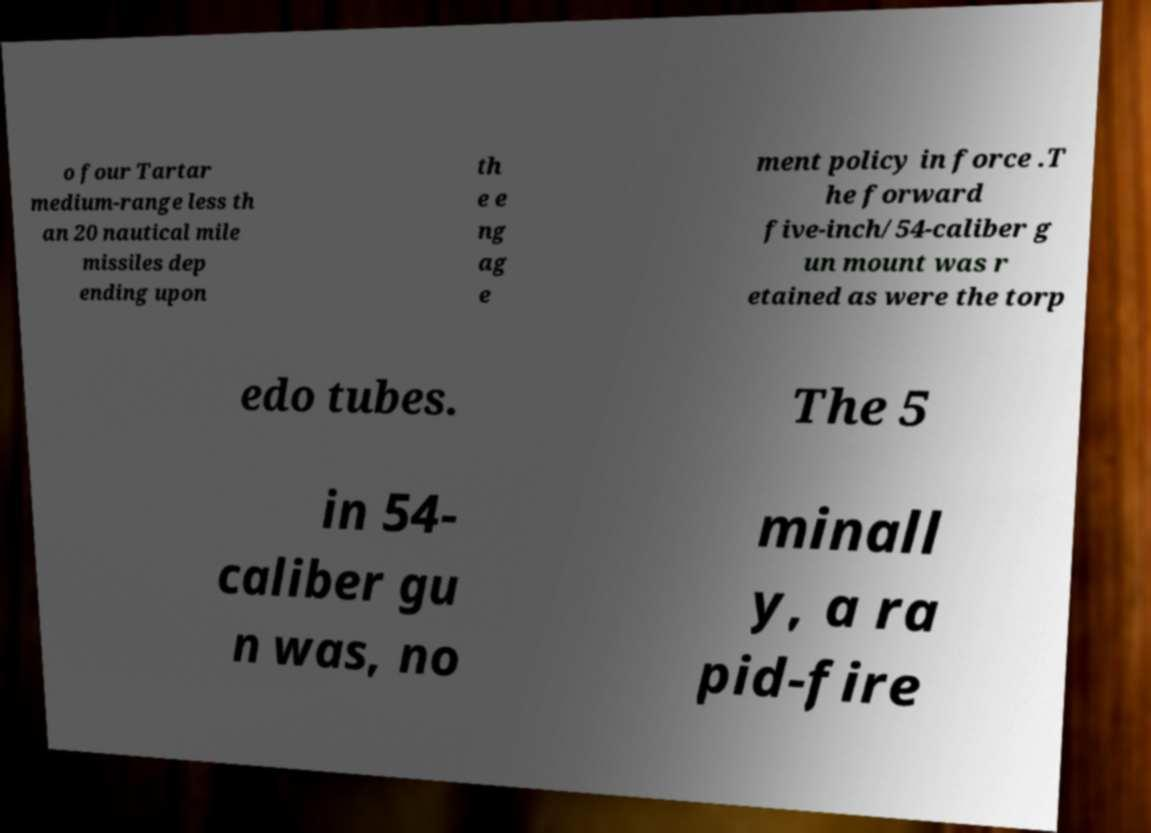Could you assist in decoding the text presented in this image and type it out clearly? o four Tartar medium-range less th an 20 nautical mile missiles dep ending upon th e e ng ag e ment policy in force .T he forward five-inch/54-caliber g un mount was r etained as were the torp edo tubes. The 5 in 54- caliber gu n was, no minall y, a ra pid-fire 